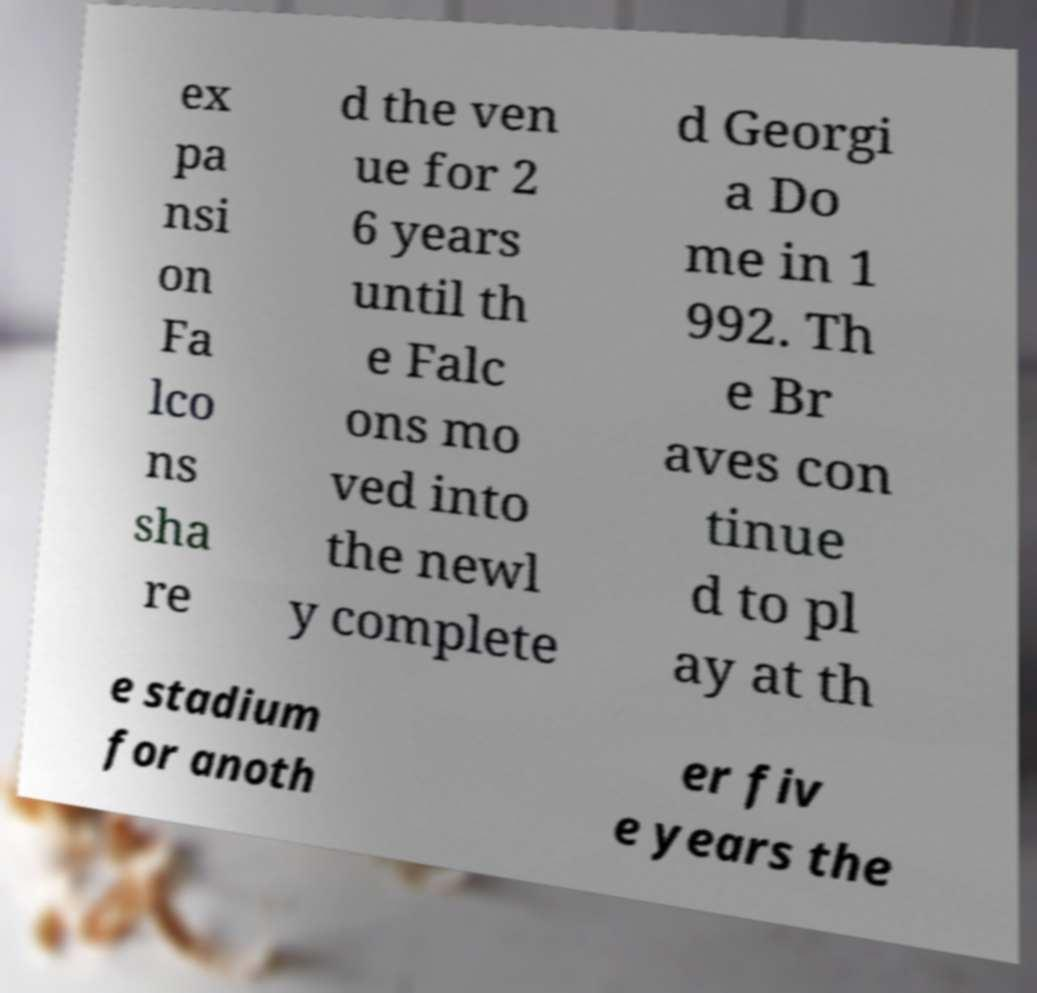For documentation purposes, I need the text within this image transcribed. Could you provide that? ex pa nsi on Fa lco ns sha re d the ven ue for 2 6 years until th e Falc ons mo ved into the newl y complete d Georgi a Do me in 1 992. Th e Br aves con tinue d to pl ay at th e stadium for anoth er fiv e years the 